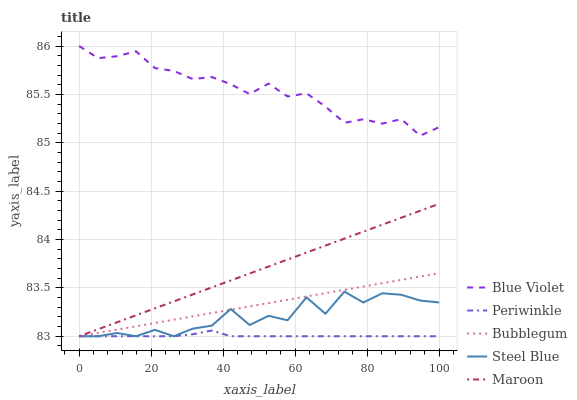Does Bubblegum have the minimum area under the curve?
Answer yes or no. No. Does Bubblegum have the maximum area under the curve?
Answer yes or no. No. Is Periwinkle the smoothest?
Answer yes or no. No. Is Periwinkle the roughest?
Answer yes or no. No. Does Blue Violet have the lowest value?
Answer yes or no. No. Does Bubblegum have the highest value?
Answer yes or no. No. Is Periwinkle less than Blue Violet?
Answer yes or no. Yes. Is Blue Violet greater than Maroon?
Answer yes or no. Yes. Does Periwinkle intersect Blue Violet?
Answer yes or no. No. 